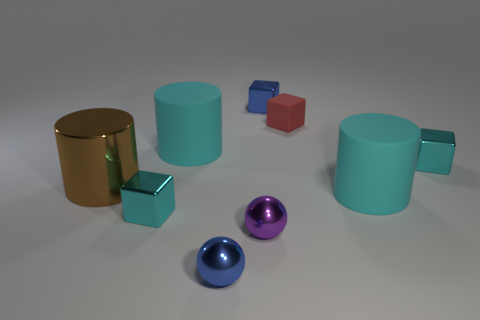Add 1 brown things. How many objects exist? 10 Subtract all cylinders. How many objects are left? 6 Subtract all tiny balls. Subtract all metallic blocks. How many objects are left? 4 Add 4 small cyan metal things. How many small cyan metal things are left? 6 Add 1 balls. How many balls exist? 3 Subtract 1 blue balls. How many objects are left? 8 